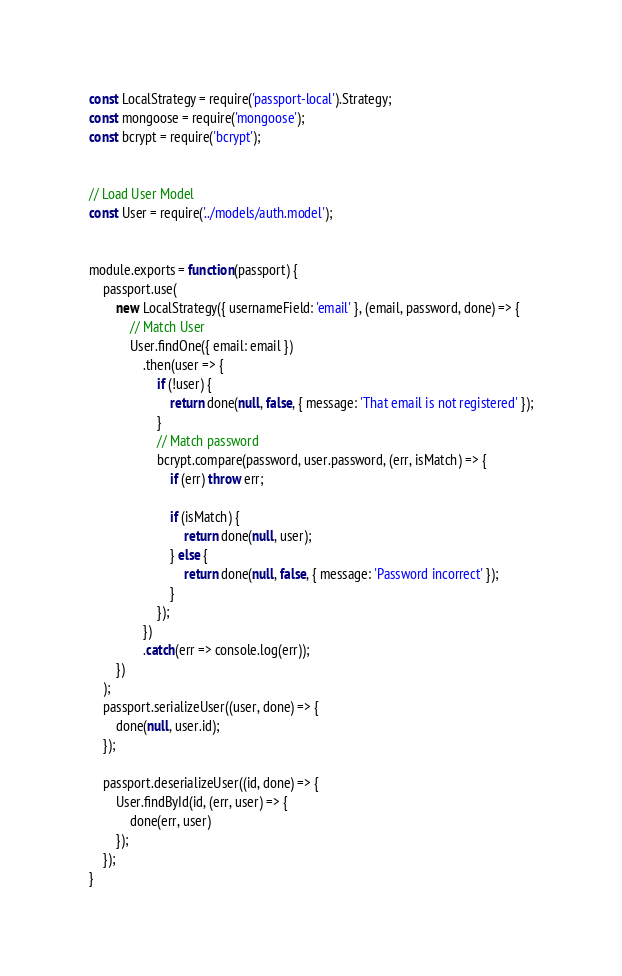<code> <loc_0><loc_0><loc_500><loc_500><_JavaScript_>const LocalStrategy = require('passport-local').Strategy;
const mongoose = require('mongoose');
const bcrypt = require('bcrypt');


// Load User Model
const User = require('../models/auth.model');


module.exports = function(passport) {
    passport.use(
        new LocalStrategy({ usernameField: 'email' }, (email, password, done) => {
            // Match User
            User.findOne({ email: email })
                .then(user => {
                    if (!user) {
                        return done(null, false, { message: 'That email is not registered' });
                    }
                    // Match password
                    bcrypt.compare(password, user.password, (err, isMatch) => {
                        if (err) throw err;

                        if (isMatch) {
                            return done(null, user);
                        } else {
                            return done(null, false, { message: 'Password incorrect' });
                        }
                    });
                })
                .catch(err => console.log(err));
        })
    );
    passport.serializeUser((user, done) => {
        done(null, user.id);
    });

    passport.deserializeUser((id, done) => {
        User.findById(id, (err, user) => {
            done(err, user)
        });
    });
}</code> 